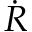<formula> <loc_0><loc_0><loc_500><loc_500>\dot { R }</formula> 